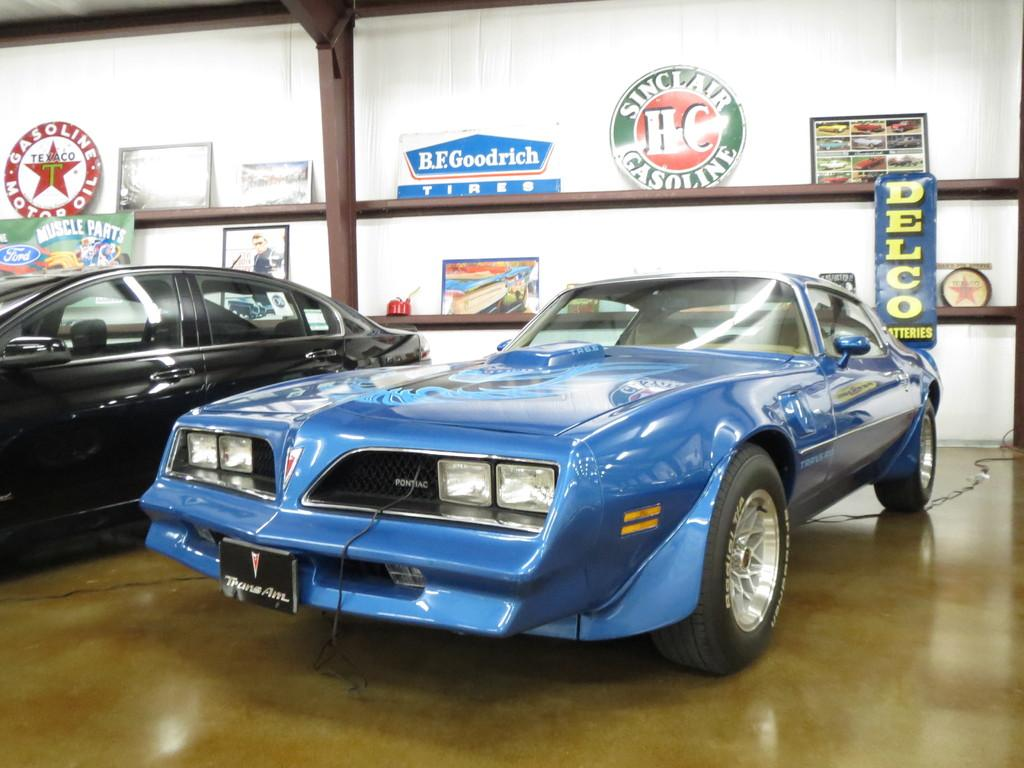What type of vehicles can be seen in the image? There are cars in the image. What is on the floor in the image? There is a wire on the floor in the image. What is located behind the cars in the image? There is a pole behind the cars in the image. What is stored in the racks in the image? There are boards in the racks in the image. What can be seen in the background of the image? There is a white wall visible in the background of the image. How does the image make you feel? The image itself does not evoke a feeling, as it is a static representation of objects and does not have the ability to convey emotions. 